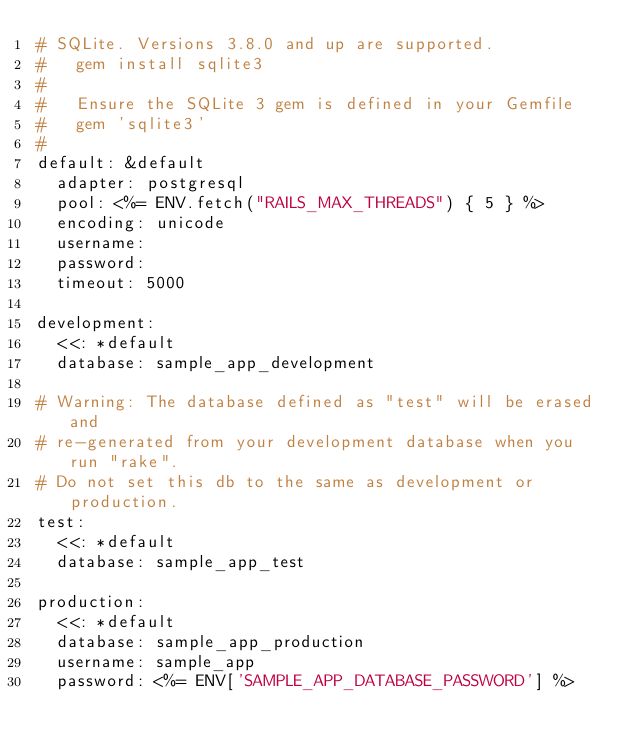Convert code to text. <code><loc_0><loc_0><loc_500><loc_500><_YAML_># SQLite. Versions 3.8.0 and up are supported.
#   gem install sqlite3
#
#   Ensure the SQLite 3 gem is defined in your Gemfile
#   gem 'sqlite3'
#
default: &default
  adapter: postgresql
  pool: <%= ENV.fetch("RAILS_MAX_THREADS") { 5 } %>
  encoding: unicode
  username: 
  password: 
  timeout: 5000

development:
  <<: *default
  database: sample_app_development

# Warning: The database defined as "test" will be erased and
# re-generated from your development database when you run "rake".
# Do not set this db to the same as development or production.
test:
  <<: *default
  database: sample_app_test

production:
  <<: *default
  database: sample_app_production
  username: sample_app
  password: <%= ENV['SAMPLE_APP_DATABASE_PASSWORD'] %>
</code> 